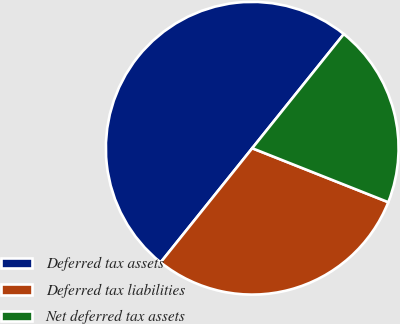Convert chart. <chart><loc_0><loc_0><loc_500><loc_500><pie_chart><fcel>Deferred tax assets<fcel>Deferred tax liabilities<fcel>Net deferred tax assets<nl><fcel>50.0%<fcel>29.75%<fcel>20.25%<nl></chart> 